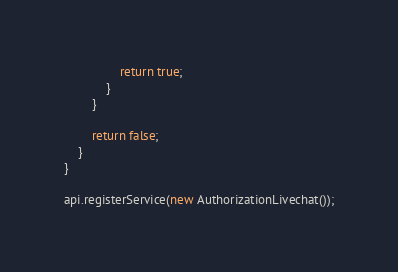<code> <loc_0><loc_0><loc_500><loc_500><_TypeScript_>				return true;
			}
		}

		return false;
	}
}

api.registerService(new AuthorizationLivechat());
</code> 